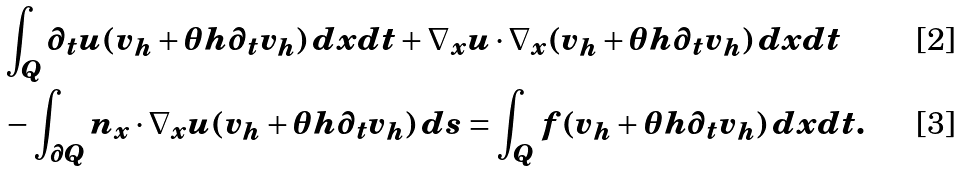Convert formula to latex. <formula><loc_0><loc_0><loc_500><loc_500>& \int _ { Q } \partial _ { t } u ( v _ { h } + \theta h \partial _ { t } v _ { h } ) \, d x d t + \nabla _ { x } u \cdot \nabla _ { x } ( v _ { h } + \theta h \partial _ { t } v _ { h } ) \, d x d t \\ & - \int _ { \partial Q } n _ { x } \cdot \nabla _ { x } u ( v _ { h } + \theta h \partial _ { t } v _ { h } ) \, d s = \int _ { Q } f ( v _ { h } + \theta h \partial _ { t } v _ { h } ) \, d x d t .</formula> 